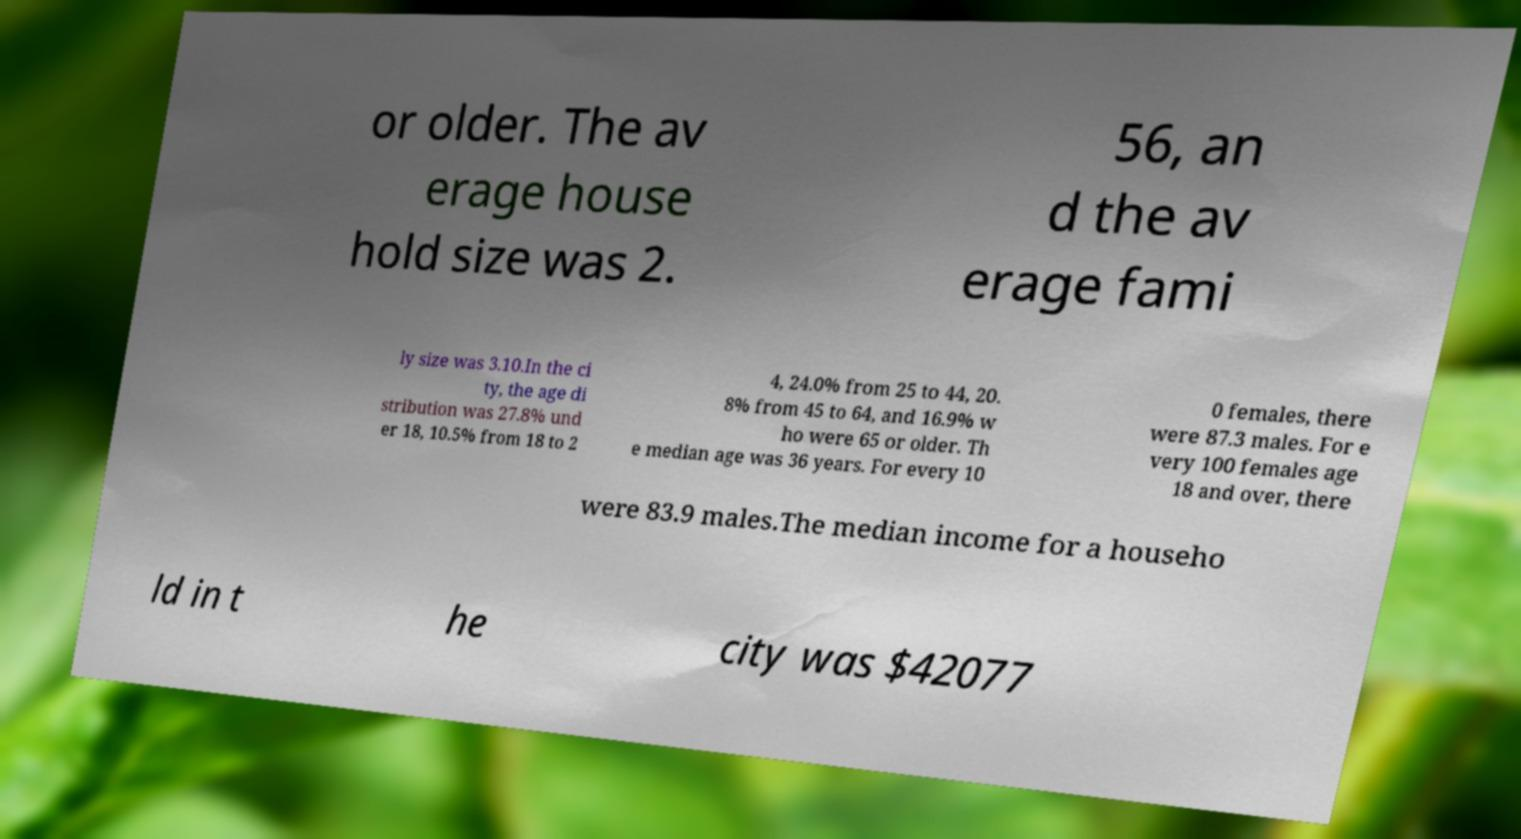I need the written content from this picture converted into text. Can you do that? or older. The av erage house hold size was 2. 56, an d the av erage fami ly size was 3.10.In the ci ty, the age di stribution was 27.8% und er 18, 10.5% from 18 to 2 4, 24.0% from 25 to 44, 20. 8% from 45 to 64, and 16.9% w ho were 65 or older. Th e median age was 36 years. For every 10 0 females, there were 87.3 males. For e very 100 females age 18 and over, there were 83.9 males.The median income for a househo ld in t he city was $42077 